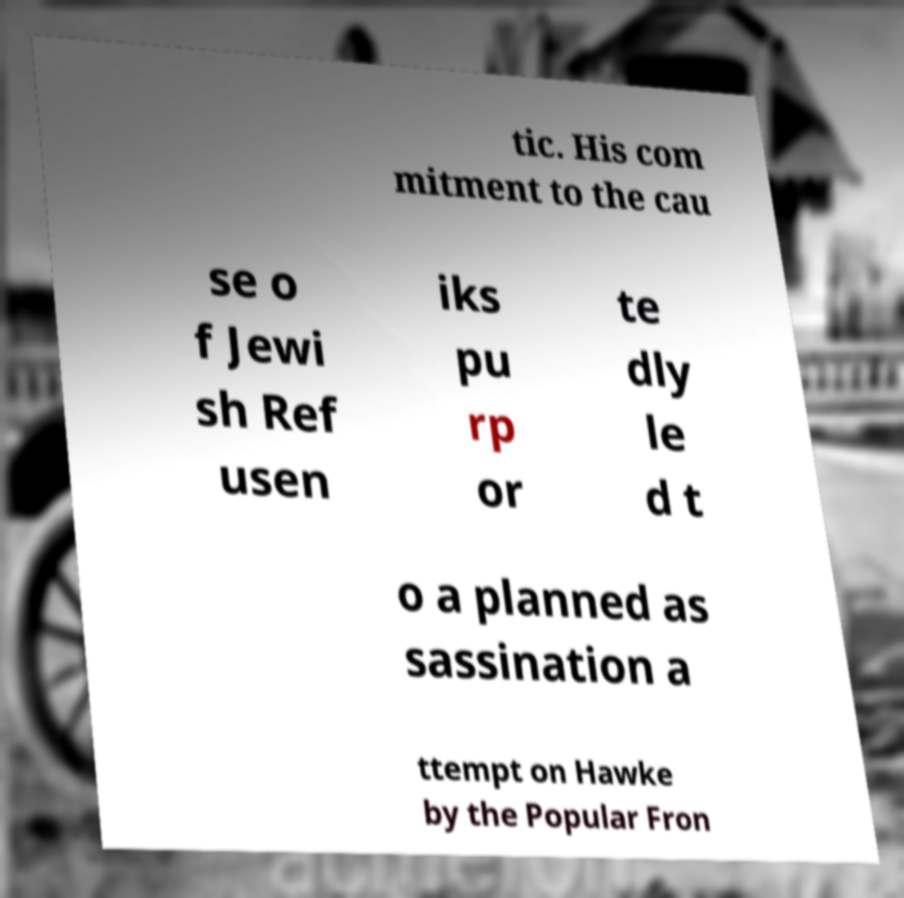Can you accurately transcribe the text from the provided image for me? tic. His com mitment to the cau se o f Jewi sh Ref usen iks pu rp or te dly le d t o a planned as sassination a ttempt on Hawke by the Popular Fron 